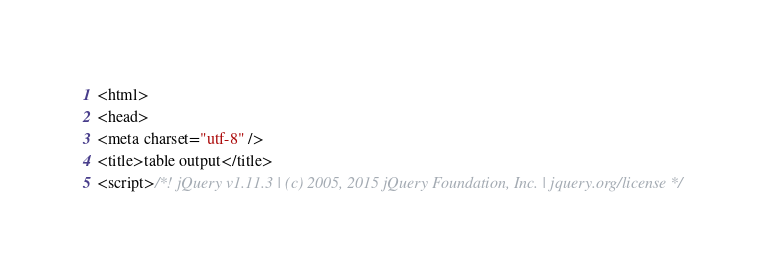Convert code to text. <code><loc_0><loc_0><loc_500><loc_500><_HTML_><html>
<head>
<meta charset="utf-8" />
<title>table output</title>
<script>/*! jQuery v1.11.3 | (c) 2005, 2015 jQuery Foundation, Inc. | jquery.org/license */</code> 